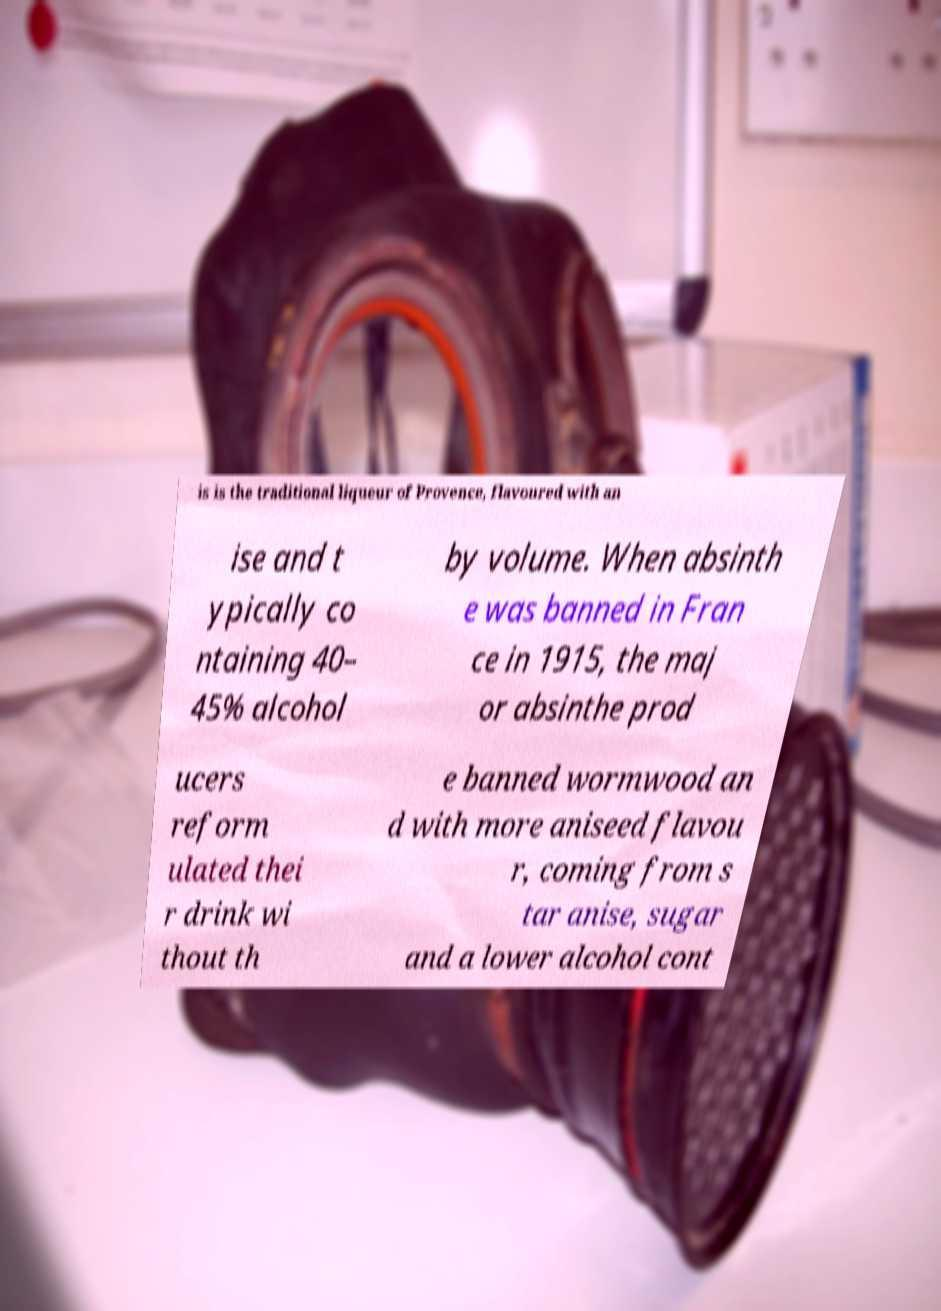Could you extract and type out the text from this image? is is the traditional liqueur of Provence, flavoured with an ise and t ypically co ntaining 40– 45% alcohol by volume. When absinth e was banned in Fran ce in 1915, the maj or absinthe prod ucers reform ulated thei r drink wi thout th e banned wormwood an d with more aniseed flavou r, coming from s tar anise, sugar and a lower alcohol cont 